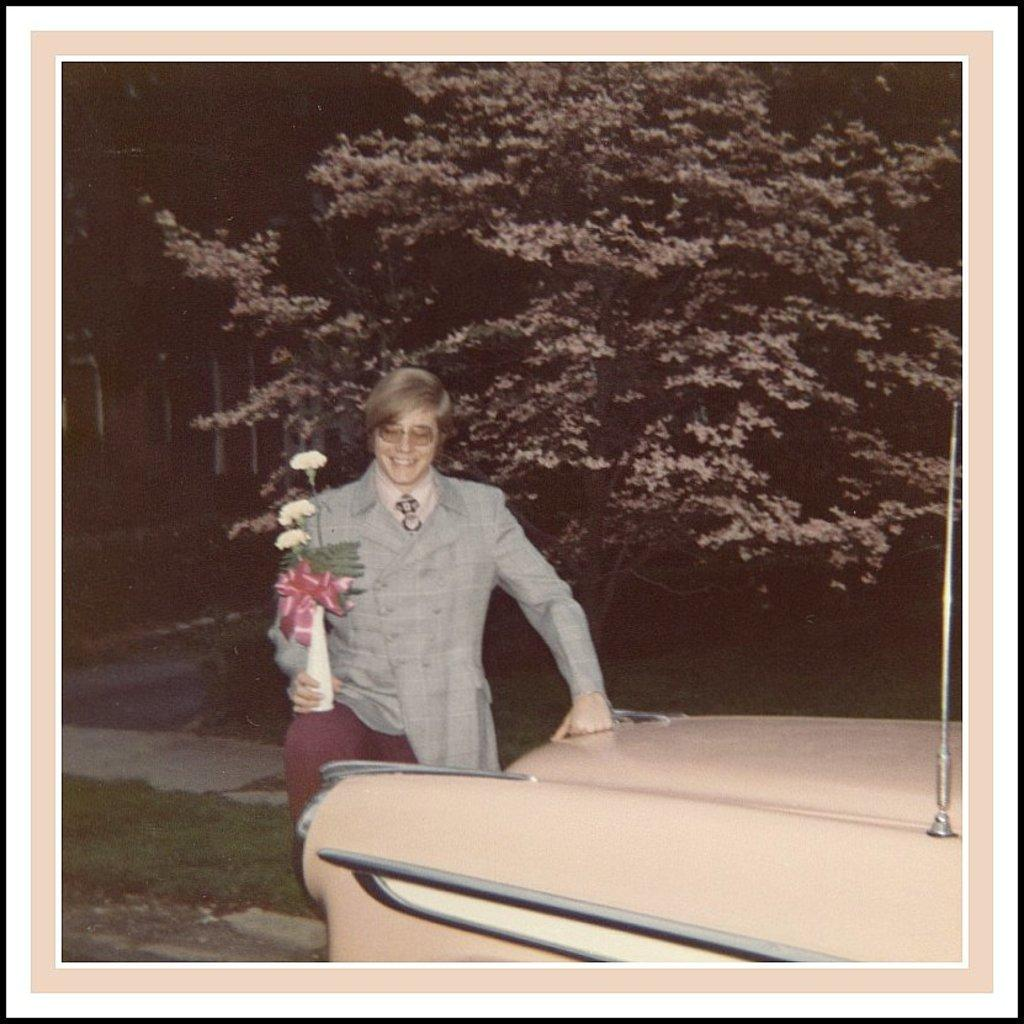What is the main subject of the image? The main subject of the image is an old photograph. What can be seen in the photograph? The photograph contains a person holding a flower vase. What type of vehicle is present in the image? There is a cream-colored car in the image. What can be seen in the background of the image? There are trees visible in the background of the image. What type of bun is the person eating in the image? There is no person eating a bun in the image; the person is holding a flower vase. What kind of toys can be seen in the image? There are no toys present in the image. 